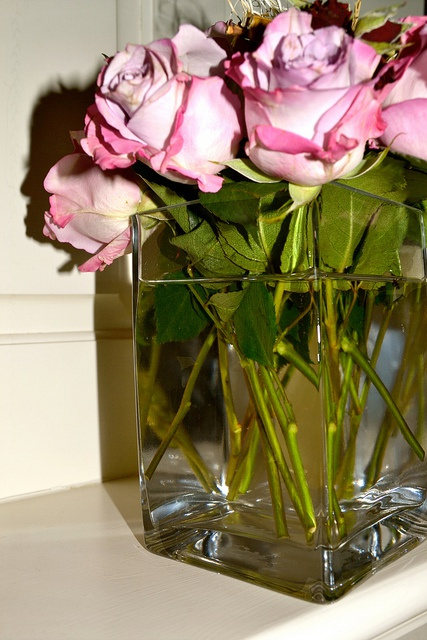Describe the objects in this image and their specific colors. I can see a vase in darkgray, olive, black, and gray tones in this image. 